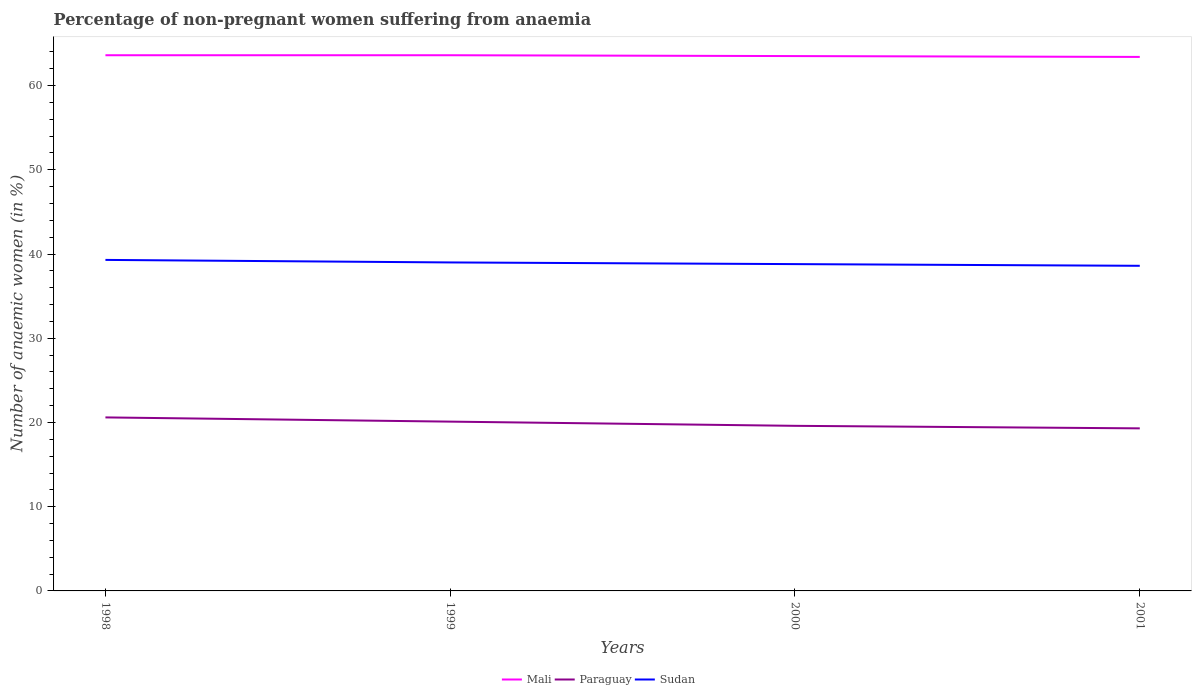How many different coloured lines are there?
Keep it short and to the point. 3. Does the line corresponding to Sudan intersect with the line corresponding to Paraguay?
Provide a short and direct response. No. Across all years, what is the maximum percentage of non-pregnant women suffering from anaemia in Mali?
Your answer should be compact. 63.4. In which year was the percentage of non-pregnant women suffering from anaemia in Paraguay maximum?
Your response must be concise. 2001. What is the total percentage of non-pregnant women suffering from anaemia in Paraguay in the graph?
Provide a succinct answer. 1.3. What is the difference between the highest and the second highest percentage of non-pregnant women suffering from anaemia in Mali?
Your answer should be very brief. 0.2. What is the difference between the highest and the lowest percentage of non-pregnant women suffering from anaemia in Sudan?
Offer a terse response. 2. Is the percentage of non-pregnant women suffering from anaemia in Paraguay strictly greater than the percentage of non-pregnant women suffering from anaemia in Mali over the years?
Provide a short and direct response. Yes. How many lines are there?
Ensure brevity in your answer.  3. What is the difference between two consecutive major ticks on the Y-axis?
Offer a terse response. 10. Are the values on the major ticks of Y-axis written in scientific E-notation?
Keep it short and to the point. No. Does the graph contain any zero values?
Provide a short and direct response. No. How many legend labels are there?
Ensure brevity in your answer.  3. How are the legend labels stacked?
Your answer should be very brief. Horizontal. What is the title of the graph?
Your response must be concise. Percentage of non-pregnant women suffering from anaemia. Does "Dominican Republic" appear as one of the legend labels in the graph?
Your response must be concise. No. What is the label or title of the Y-axis?
Your answer should be very brief. Number of anaemic women (in %). What is the Number of anaemic women (in %) of Mali in 1998?
Your response must be concise. 63.6. What is the Number of anaemic women (in %) in Paraguay in 1998?
Keep it short and to the point. 20.6. What is the Number of anaemic women (in %) in Sudan in 1998?
Provide a short and direct response. 39.3. What is the Number of anaemic women (in %) in Mali in 1999?
Give a very brief answer. 63.6. What is the Number of anaemic women (in %) of Paraguay in 1999?
Your response must be concise. 20.1. What is the Number of anaemic women (in %) in Mali in 2000?
Your answer should be compact. 63.5. What is the Number of anaemic women (in %) in Paraguay in 2000?
Ensure brevity in your answer.  19.6. What is the Number of anaemic women (in %) in Sudan in 2000?
Your answer should be compact. 38.8. What is the Number of anaemic women (in %) of Mali in 2001?
Your response must be concise. 63.4. What is the Number of anaemic women (in %) in Paraguay in 2001?
Your answer should be compact. 19.3. What is the Number of anaemic women (in %) of Sudan in 2001?
Provide a short and direct response. 38.6. Across all years, what is the maximum Number of anaemic women (in %) of Mali?
Ensure brevity in your answer.  63.6. Across all years, what is the maximum Number of anaemic women (in %) in Paraguay?
Make the answer very short. 20.6. Across all years, what is the maximum Number of anaemic women (in %) in Sudan?
Ensure brevity in your answer.  39.3. Across all years, what is the minimum Number of anaemic women (in %) in Mali?
Offer a very short reply. 63.4. Across all years, what is the minimum Number of anaemic women (in %) in Paraguay?
Your response must be concise. 19.3. Across all years, what is the minimum Number of anaemic women (in %) of Sudan?
Offer a terse response. 38.6. What is the total Number of anaemic women (in %) in Mali in the graph?
Your answer should be very brief. 254.1. What is the total Number of anaemic women (in %) in Paraguay in the graph?
Provide a succinct answer. 79.6. What is the total Number of anaemic women (in %) in Sudan in the graph?
Your response must be concise. 155.7. What is the difference between the Number of anaemic women (in %) in Paraguay in 1998 and that in 1999?
Give a very brief answer. 0.5. What is the difference between the Number of anaemic women (in %) in Sudan in 1998 and that in 1999?
Provide a succinct answer. 0.3. What is the difference between the Number of anaemic women (in %) of Paraguay in 1998 and that in 2000?
Offer a very short reply. 1. What is the difference between the Number of anaemic women (in %) in Mali in 1998 and that in 2001?
Give a very brief answer. 0.2. What is the difference between the Number of anaemic women (in %) in Paraguay in 1998 and that in 2001?
Offer a very short reply. 1.3. What is the difference between the Number of anaemic women (in %) in Sudan in 1998 and that in 2001?
Your answer should be compact. 0.7. What is the difference between the Number of anaemic women (in %) of Paraguay in 1999 and that in 2001?
Your answer should be compact. 0.8. What is the difference between the Number of anaemic women (in %) in Mali in 2000 and that in 2001?
Make the answer very short. 0.1. What is the difference between the Number of anaemic women (in %) in Sudan in 2000 and that in 2001?
Offer a terse response. 0.2. What is the difference between the Number of anaemic women (in %) of Mali in 1998 and the Number of anaemic women (in %) of Paraguay in 1999?
Offer a terse response. 43.5. What is the difference between the Number of anaemic women (in %) in Mali in 1998 and the Number of anaemic women (in %) in Sudan in 1999?
Keep it short and to the point. 24.6. What is the difference between the Number of anaemic women (in %) in Paraguay in 1998 and the Number of anaemic women (in %) in Sudan in 1999?
Provide a succinct answer. -18.4. What is the difference between the Number of anaemic women (in %) in Mali in 1998 and the Number of anaemic women (in %) in Paraguay in 2000?
Provide a succinct answer. 44. What is the difference between the Number of anaemic women (in %) of Mali in 1998 and the Number of anaemic women (in %) of Sudan in 2000?
Keep it short and to the point. 24.8. What is the difference between the Number of anaemic women (in %) of Paraguay in 1998 and the Number of anaemic women (in %) of Sudan in 2000?
Provide a short and direct response. -18.2. What is the difference between the Number of anaemic women (in %) of Mali in 1998 and the Number of anaemic women (in %) of Paraguay in 2001?
Your answer should be very brief. 44.3. What is the difference between the Number of anaemic women (in %) of Mali in 1998 and the Number of anaemic women (in %) of Sudan in 2001?
Provide a succinct answer. 25. What is the difference between the Number of anaemic women (in %) in Paraguay in 1998 and the Number of anaemic women (in %) in Sudan in 2001?
Offer a very short reply. -18. What is the difference between the Number of anaemic women (in %) of Mali in 1999 and the Number of anaemic women (in %) of Paraguay in 2000?
Your answer should be compact. 44. What is the difference between the Number of anaemic women (in %) in Mali in 1999 and the Number of anaemic women (in %) in Sudan in 2000?
Offer a terse response. 24.8. What is the difference between the Number of anaemic women (in %) of Paraguay in 1999 and the Number of anaemic women (in %) of Sudan in 2000?
Make the answer very short. -18.7. What is the difference between the Number of anaemic women (in %) in Mali in 1999 and the Number of anaemic women (in %) in Paraguay in 2001?
Give a very brief answer. 44.3. What is the difference between the Number of anaemic women (in %) of Paraguay in 1999 and the Number of anaemic women (in %) of Sudan in 2001?
Make the answer very short. -18.5. What is the difference between the Number of anaemic women (in %) in Mali in 2000 and the Number of anaemic women (in %) in Paraguay in 2001?
Your answer should be compact. 44.2. What is the difference between the Number of anaemic women (in %) of Mali in 2000 and the Number of anaemic women (in %) of Sudan in 2001?
Offer a terse response. 24.9. What is the difference between the Number of anaemic women (in %) in Paraguay in 2000 and the Number of anaemic women (in %) in Sudan in 2001?
Your answer should be compact. -19. What is the average Number of anaemic women (in %) in Mali per year?
Keep it short and to the point. 63.52. What is the average Number of anaemic women (in %) in Paraguay per year?
Your answer should be very brief. 19.9. What is the average Number of anaemic women (in %) in Sudan per year?
Ensure brevity in your answer.  38.92. In the year 1998, what is the difference between the Number of anaemic women (in %) in Mali and Number of anaemic women (in %) in Sudan?
Offer a very short reply. 24.3. In the year 1998, what is the difference between the Number of anaemic women (in %) of Paraguay and Number of anaemic women (in %) of Sudan?
Ensure brevity in your answer.  -18.7. In the year 1999, what is the difference between the Number of anaemic women (in %) of Mali and Number of anaemic women (in %) of Paraguay?
Offer a very short reply. 43.5. In the year 1999, what is the difference between the Number of anaemic women (in %) of Mali and Number of anaemic women (in %) of Sudan?
Offer a very short reply. 24.6. In the year 1999, what is the difference between the Number of anaemic women (in %) in Paraguay and Number of anaemic women (in %) in Sudan?
Offer a terse response. -18.9. In the year 2000, what is the difference between the Number of anaemic women (in %) in Mali and Number of anaemic women (in %) in Paraguay?
Ensure brevity in your answer.  43.9. In the year 2000, what is the difference between the Number of anaemic women (in %) of Mali and Number of anaemic women (in %) of Sudan?
Give a very brief answer. 24.7. In the year 2000, what is the difference between the Number of anaemic women (in %) of Paraguay and Number of anaemic women (in %) of Sudan?
Your response must be concise. -19.2. In the year 2001, what is the difference between the Number of anaemic women (in %) of Mali and Number of anaemic women (in %) of Paraguay?
Your answer should be very brief. 44.1. In the year 2001, what is the difference between the Number of anaemic women (in %) of Mali and Number of anaemic women (in %) of Sudan?
Offer a very short reply. 24.8. In the year 2001, what is the difference between the Number of anaemic women (in %) in Paraguay and Number of anaemic women (in %) in Sudan?
Provide a short and direct response. -19.3. What is the ratio of the Number of anaemic women (in %) in Mali in 1998 to that in 1999?
Your answer should be very brief. 1. What is the ratio of the Number of anaemic women (in %) in Paraguay in 1998 to that in 1999?
Offer a very short reply. 1.02. What is the ratio of the Number of anaemic women (in %) of Sudan in 1998 to that in 1999?
Your answer should be compact. 1.01. What is the ratio of the Number of anaemic women (in %) of Paraguay in 1998 to that in 2000?
Keep it short and to the point. 1.05. What is the ratio of the Number of anaemic women (in %) of Sudan in 1998 to that in 2000?
Your answer should be very brief. 1.01. What is the ratio of the Number of anaemic women (in %) in Mali in 1998 to that in 2001?
Your answer should be compact. 1. What is the ratio of the Number of anaemic women (in %) in Paraguay in 1998 to that in 2001?
Give a very brief answer. 1.07. What is the ratio of the Number of anaemic women (in %) of Sudan in 1998 to that in 2001?
Give a very brief answer. 1.02. What is the ratio of the Number of anaemic women (in %) of Mali in 1999 to that in 2000?
Offer a terse response. 1. What is the ratio of the Number of anaemic women (in %) in Paraguay in 1999 to that in 2000?
Provide a succinct answer. 1.03. What is the ratio of the Number of anaemic women (in %) of Sudan in 1999 to that in 2000?
Offer a very short reply. 1.01. What is the ratio of the Number of anaemic women (in %) of Paraguay in 1999 to that in 2001?
Your answer should be compact. 1.04. What is the ratio of the Number of anaemic women (in %) of Sudan in 1999 to that in 2001?
Ensure brevity in your answer.  1.01. What is the ratio of the Number of anaemic women (in %) in Mali in 2000 to that in 2001?
Offer a terse response. 1. What is the ratio of the Number of anaemic women (in %) of Paraguay in 2000 to that in 2001?
Keep it short and to the point. 1.02. What is the difference between the highest and the second highest Number of anaemic women (in %) of Mali?
Offer a very short reply. 0. What is the difference between the highest and the second highest Number of anaemic women (in %) of Sudan?
Give a very brief answer. 0.3. What is the difference between the highest and the lowest Number of anaemic women (in %) in Sudan?
Ensure brevity in your answer.  0.7. 